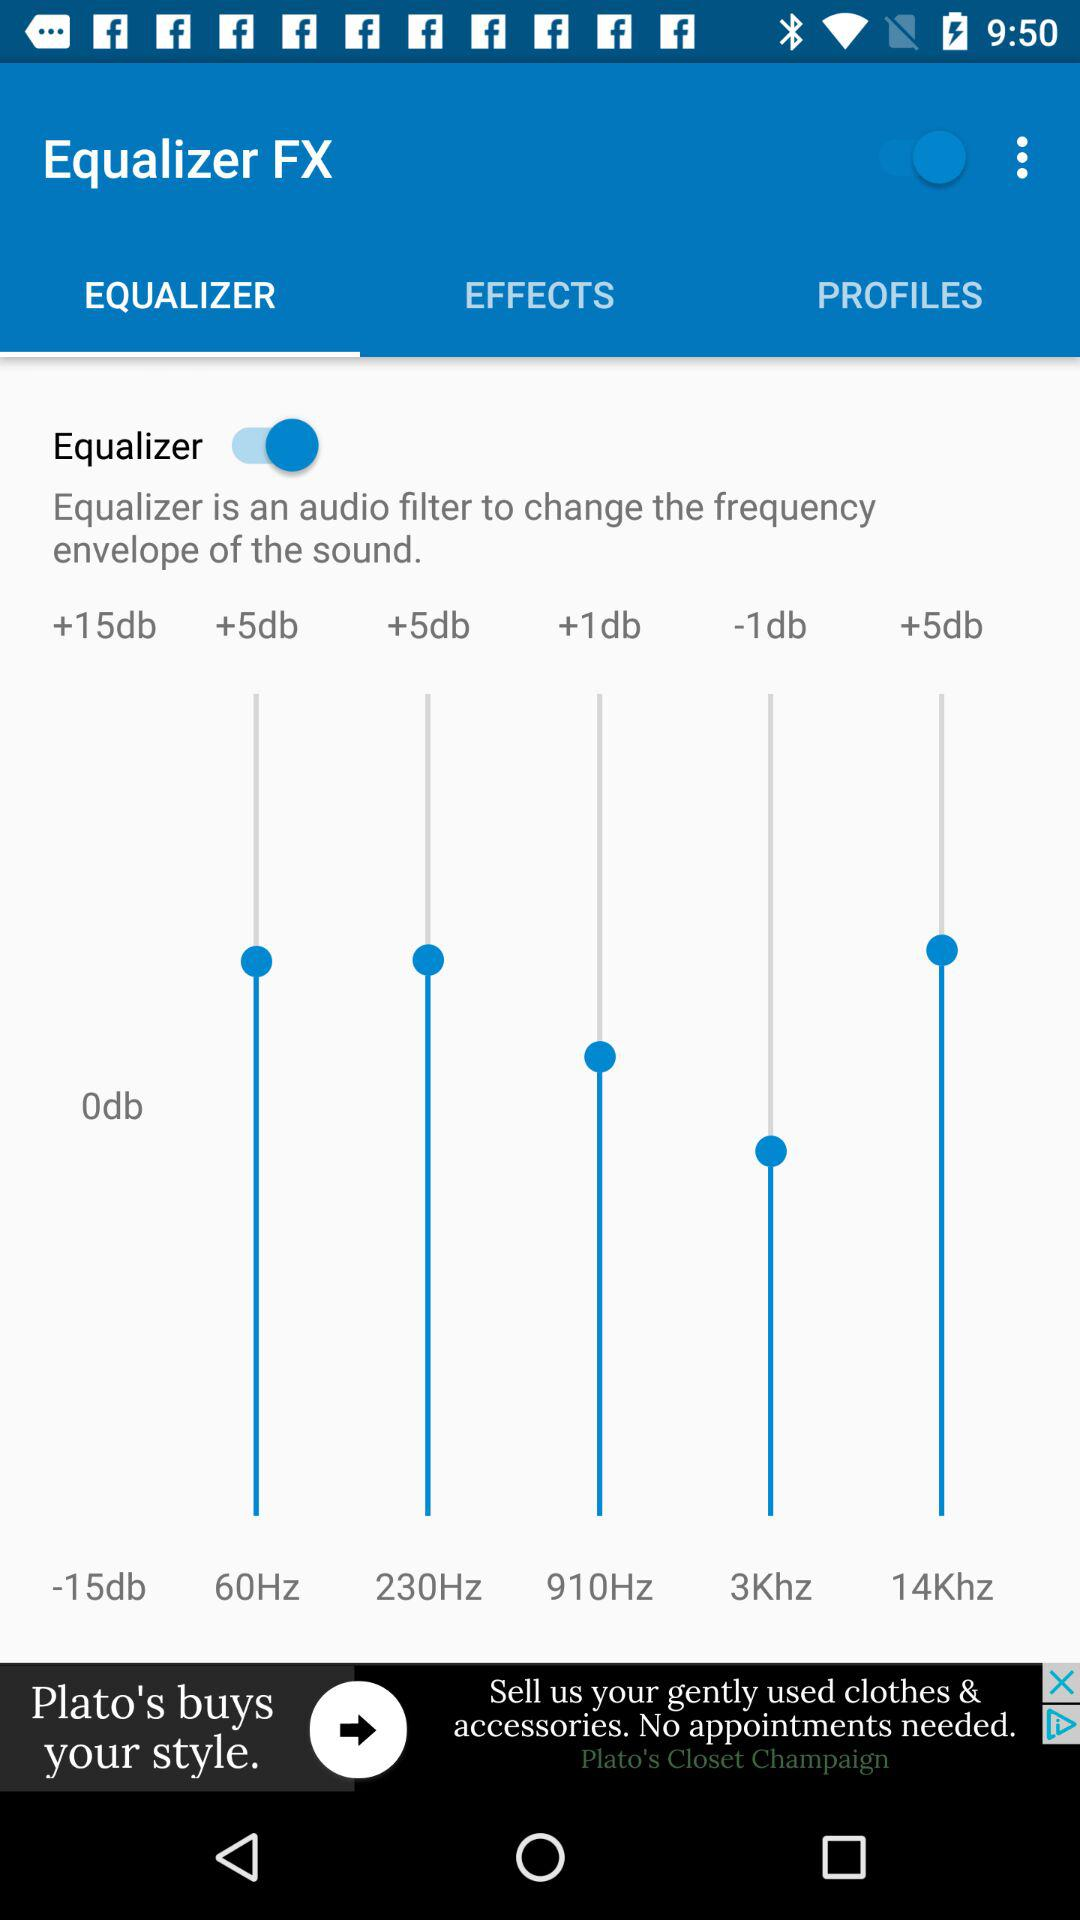What is the status of "Equalizer FX"? The status is "on". 